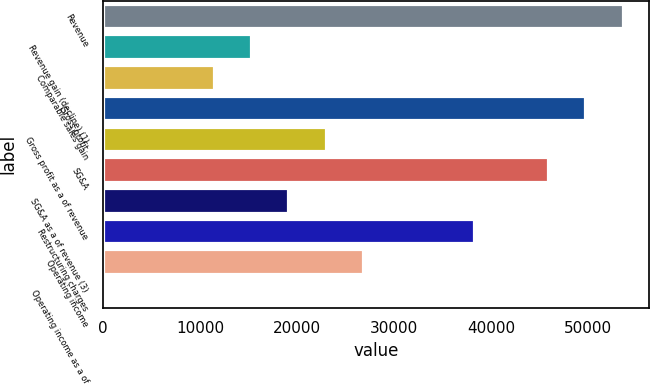Convert chart. <chart><loc_0><loc_0><loc_500><loc_500><bar_chart><fcel>Revenue<fcel>Revenue gain (decline) (1)<fcel>Comparable sales gain<fcel>Gross profit<fcel>Gross profit as a of revenue<fcel>SG&A<fcel>SG&A as a of revenue (3)<fcel>Restructuring charges<fcel>Operating income<fcel>Operating income as a of<nl><fcel>53552.7<fcel>15300.9<fcel>11475.7<fcel>49727.5<fcel>22951.3<fcel>45902.4<fcel>19126.1<fcel>38252<fcel>26776.5<fcel>0.2<nl></chart> 